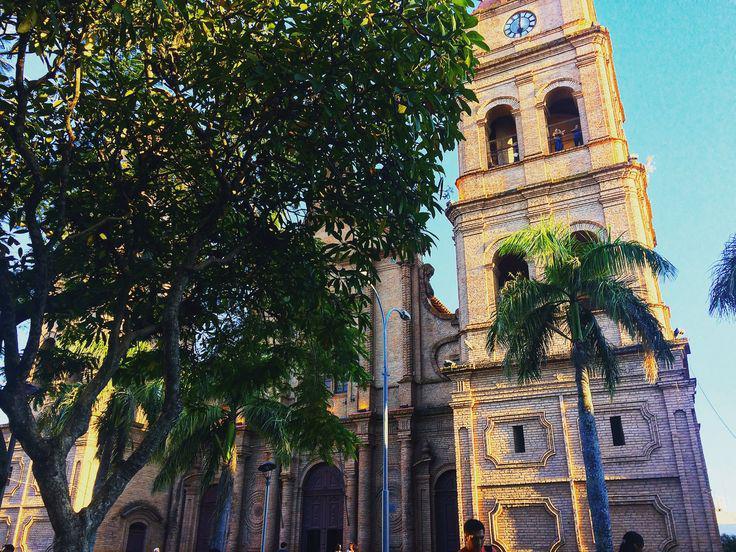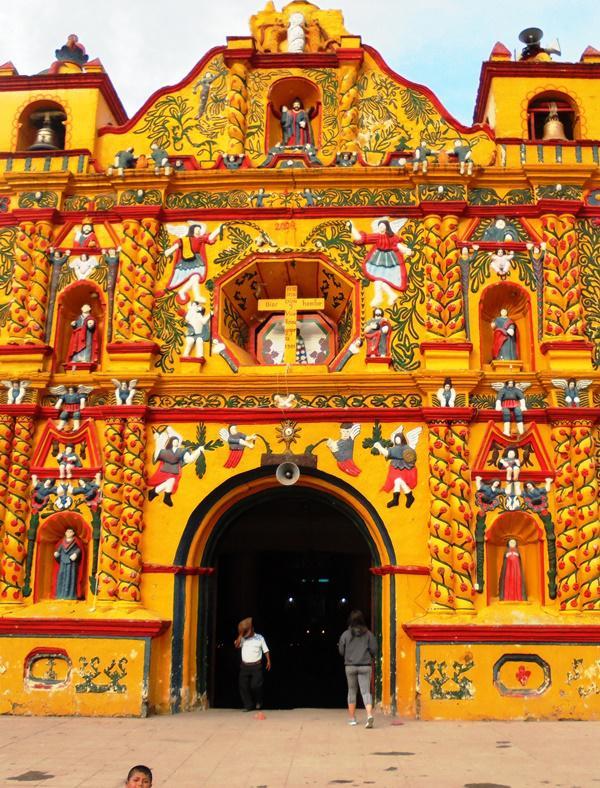The first image is the image on the left, the second image is the image on the right. For the images displayed, is the sentence "The left and right image contains no less than four crosses." factually correct? Answer yes or no. No. The first image is the image on the left, the second image is the image on the right. For the images displayed, is the sentence "The right image shows a beige building with a cone-shaped roof topped with a cross above a cylindrical tower." factually correct? Answer yes or no. No. 